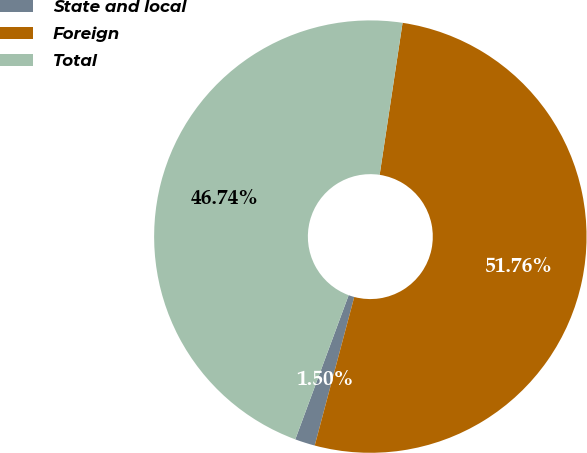Convert chart. <chart><loc_0><loc_0><loc_500><loc_500><pie_chart><fcel>State and local<fcel>Foreign<fcel>Total<nl><fcel>1.5%<fcel>51.76%<fcel>46.74%<nl></chart> 